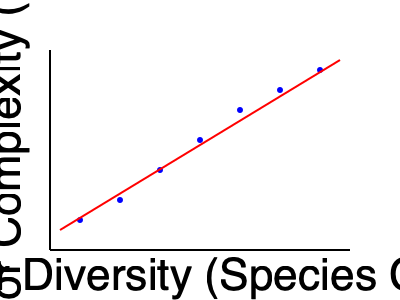Based on the scatter plot showing the relationship between flower diversity and honey flavor complexity, calculate the Pearson correlation coefficient (r) between these two variables. What does this value indicate about the strength and direction of the relationship? To calculate the Pearson correlation coefficient (r), we'll follow these steps:

1. Identify the data points from the graph:
   (10, 3), (20, 5), (30, 7), (40, 8), (50, 9), (60, 9.5), (70, 10)

2. Calculate the means:
   $\bar{x} = \frac{10 + 20 + 30 + 40 + 50 + 60 + 70}{7} = 40$
   $\bar{y} = \frac{3 + 5 + 7 + 8 + 9 + 9.5 + 10}{7} = 7.36$

3. Calculate the standard deviations:
   $s_x = \sqrt{\frac{\sum(x_i - \bar{x})^2}{n-1}} = 22.36$
   $s_y = \sqrt{\frac{\sum(y_i - \bar{y})^2}{n-1}} = 2.62$

4. Calculate the correlation coefficient:
   $r = \frac{\sum(x_i - \bar{x})(y_i - \bar{y})}{(n-1)s_x s_y}$

   $r = \frac{(10-40)(3-7.36) + (20-40)(5-7.36) + ... + (70-40)(10-7.36)}{6 \times 22.36 \times 2.62}$

   $r \approx 0.98$

5. Interpret the result:
   The correlation coefficient of 0.98 indicates a very strong positive relationship between flower diversity and honey flavor complexity. As flower diversity increases, honey flavor complexity tends to increase as well.
Answer: r ≈ 0.98; very strong positive correlation 